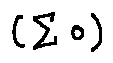<formula> <loc_0><loc_0><loc_500><loc_500>( \sum o )</formula> 